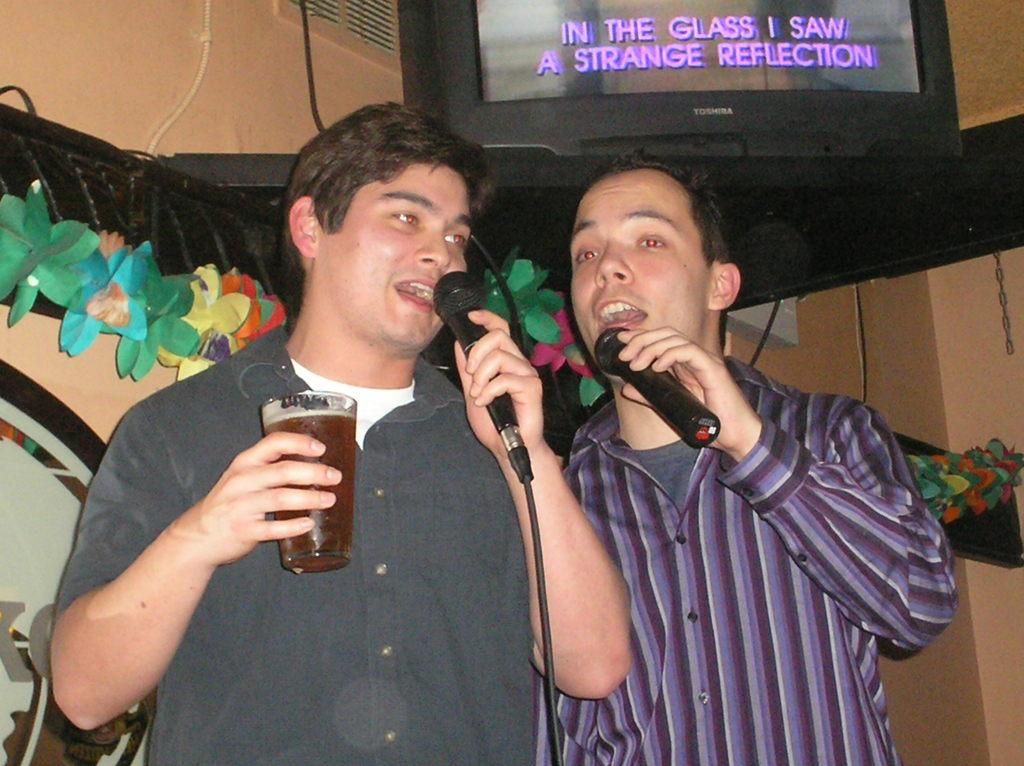How many people are in the image? There are two men in the image. What are the men doing in the image? The men are singing on a mic and holding beer glasses. What is located above the men in the image? There is a TV screen above the men. What decorative elements can be seen behind the men? There are flower ribbons visible behind the men. What type of glue is being used to hold the microphone in the image? There is no glue present in the image, and the microphone is not being held in place by any adhesive. 